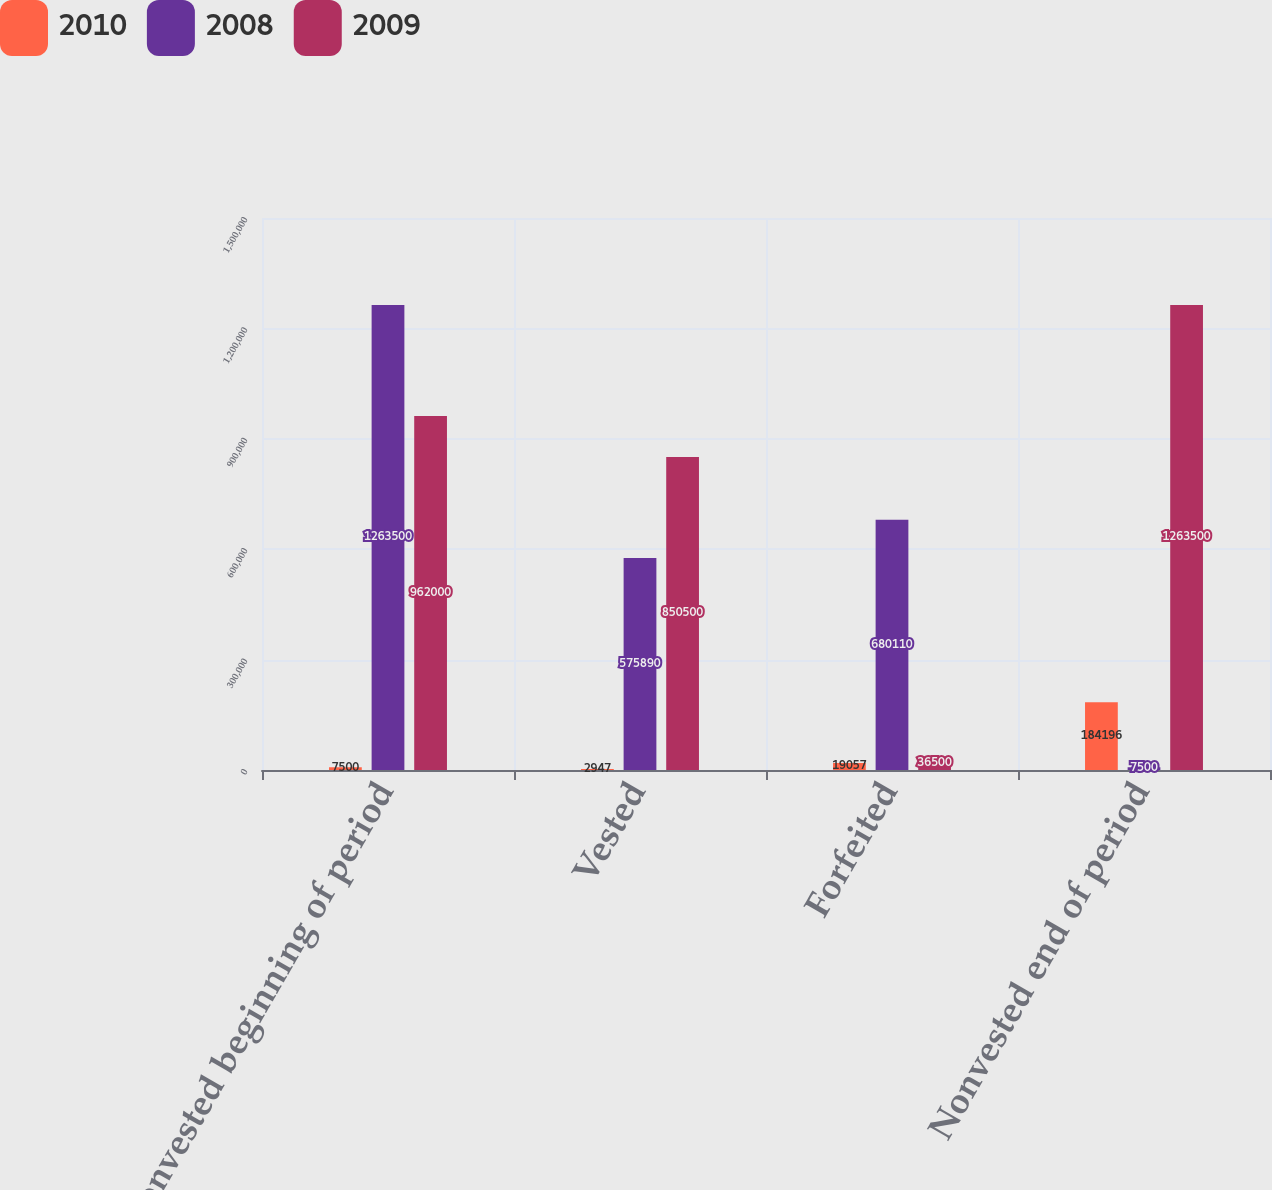<chart> <loc_0><loc_0><loc_500><loc_500><stacked_bar_chart><ecel><fcel>Nonvested beginning of period<fcel>Vested<fcel>Forfeited<fcel>Nonvested end of period<nl><fcel>2010<fcel>7500<fcel>2947<fcel>19057<fcel>184196<nl><fcel>2008<fcel>1.2635e+06<fcel>575890<fcel>680110<fcel>7500<nl><fcel>2009<fcel>962000<fcel>850500<fcel>36500<fcel>1.2635e+06<nl></chart> 